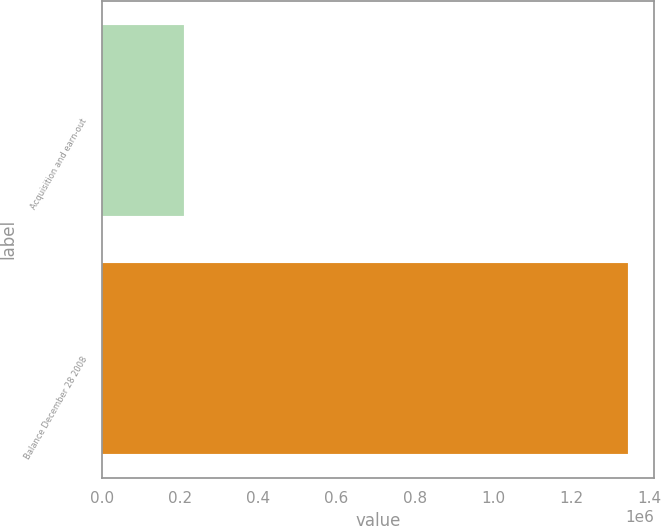Convert chart to OTSL. <chart><loc_0><loc_0><loc_500><loc_500><bar_chart><fcel>Acquisition and earn-out<fcel>Balance December 28 2008<nl><fcel>208196<fcel>1.34544e+06<nl></chart> 